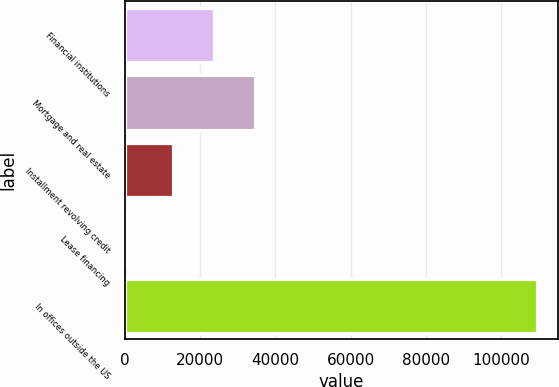Convert chart to OTSL. <chart><loc_0><loc_0><loc_500><loc_500><bar_chart><fcel>Financial institutions<fcel>Mortgage and real estate<fcel>Installment revolving credit<fcel>Lease financing<fcel>In offices outside the US<nl><fcel>23625.1<fcel>34520.2<fcel>12730<fcel>546<fcel>109497<nl></chart> 